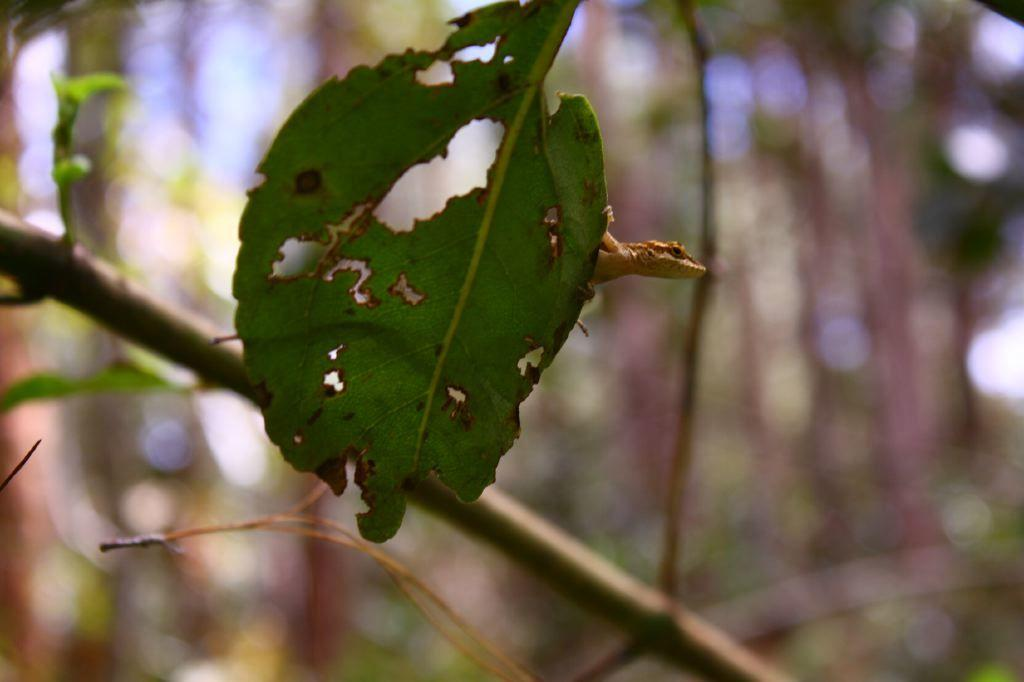What type of animal is in the image? There is a lizard in the image. Where is the lizard located? The lizard is on a leaf. What can be seen behind the leaf? There is a stem behind the leaf. How would you describe the background of the image? The background of the image is blurred. What type of toys can be seen in the image? There are no toys present in the image; it features a lizard on a leaf with a blurred background. 